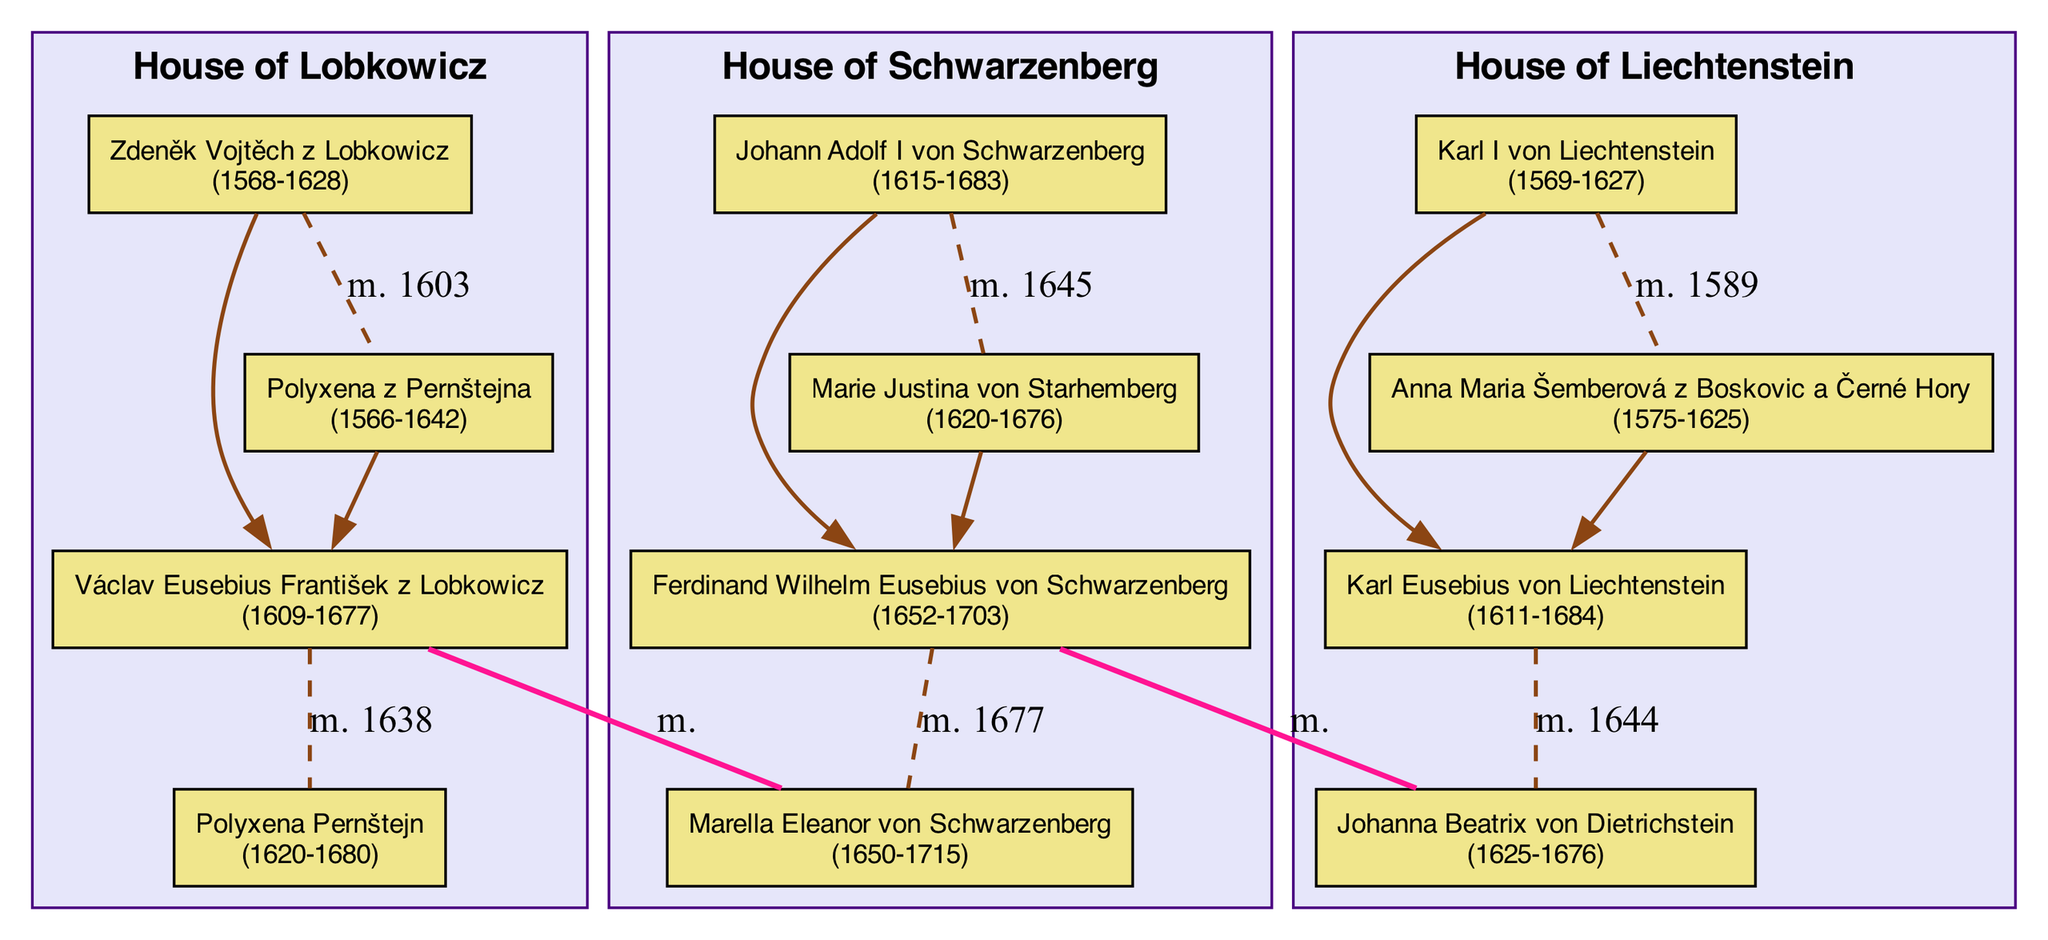What is the birth year of Václav Eusebius František z Lobkowicz? The diagram shows Václav Eusebius František z Lobkowicz with his birth year indicated as 1609.
Answer: 1609 How many marriages are listed for Johann Adolf I von Schwarzenberg? The diagram displays that Johann Adolf I von Schwarzenberg has one marriage listed, to Marie Justina von Starhemberg in 1645.
Answer: 1 Who is the spouse of Ferdinand Wilhelm Eusebius von Schwarzenberg? According to the diagram, the spouse of Ferdinand Wilhelm Eusebius von Schwarzenberg is Marella Eleanor von Schwarzenberg.
Answer: Marella Eleanor von Schwarzenberg Which family does Polyxena Pernštejn belong to? The diagram indicates that Polyxena Pernštejn is a member of the House of Lobkowicz.
Answer: House of Lobkowicz Which two members are connected by an inter-family marriage? The diagram shows an inter-family marriage between Václav Eusebius František z Lobkowicz and Marella Eleanor von Schwarzenberg.
Answer: Václav Eusebius František z Lobkowicz and Marella Eleanor von Schwarzenberg What is the death year of Johanna Beatrix von Dietrichstein? The diagram clearly displays that Johanna Beatrix von Dietrichstein died in 1676.
Answer: 1676 Who are the parents of Karl Eusebius von Liechtenstein? The diagram lists Karl I von Liechtenstein and Anna Maria Šemberová z Boskovic a Černé Hory as the parents of Karl Eusebius von Liechtenstein.
Answer: Karl I von Liechtenstein and Anna Maria Šemberová z Boskovic a Černé Hory What year did Zdeněk Vojtěch z Lobkowicz marry Polyxena z Pernštejna? Referring to the diagram, Zdeněk Vojtěch z Lobkowicz married Polyxena z Pernštejna in the year 1603.
Answer: 1603 How many children does Johann Adolf I von Schwarzenberg have? The diagram reveals that Johann Adolf I von Schwarzenberg has one child, Ferdinand Wilhelm Eusebius von Schwarzenberg.
Answer: 1 